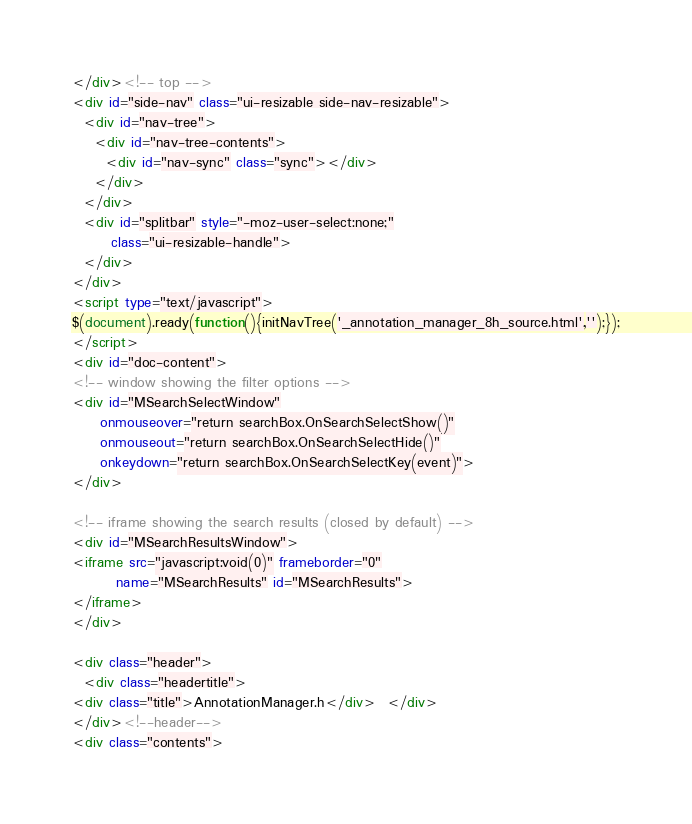<code> <loc_0><loc_0><loc_500><loc_500><_HTML_></div><!-- top -->
<div id="side-nav" class="ui-resizable side-nav-resizable">
  <div id="nav-tree">
    <div id="nav-tree-contents">
      <div id="nav-sync" class="sync"></div>
    </div>
  </div>
  <div id="splitbar" style="-moz-user-select:none;" 
       class="ui-resizable-handle">
  </div>
</div>
<script type="text/javascript">
$(document).ready(function(){initNavTree('_annotation_manager_8h_source.html','');});
</script>
<div id="doc-content">
<!-- window showing the filter options -->
<div id="MSearchSelectWindow"
     onmouseover="return searchBox.OnSearchSelectShow()"
     onmouseout="return searchBox.OnSearchSelectHide()"
     onkeydown="return searchBox.OnSearchSelectKey(event)">
</div>

<!-- iframe showing the search results (closed by default) -->
<div id="MSearchResultsWindow">
<iframe src="javascript:void(0)" frameborder="0" 
        name="MSearchResults" id="MSearchResults">
</iframe>
</div>

<div class="header">
  <div class="headertitle">
<div class="title">AnnotationManager.h</div>  </div>
</div><!--header-->
<div class="contents"></code> 